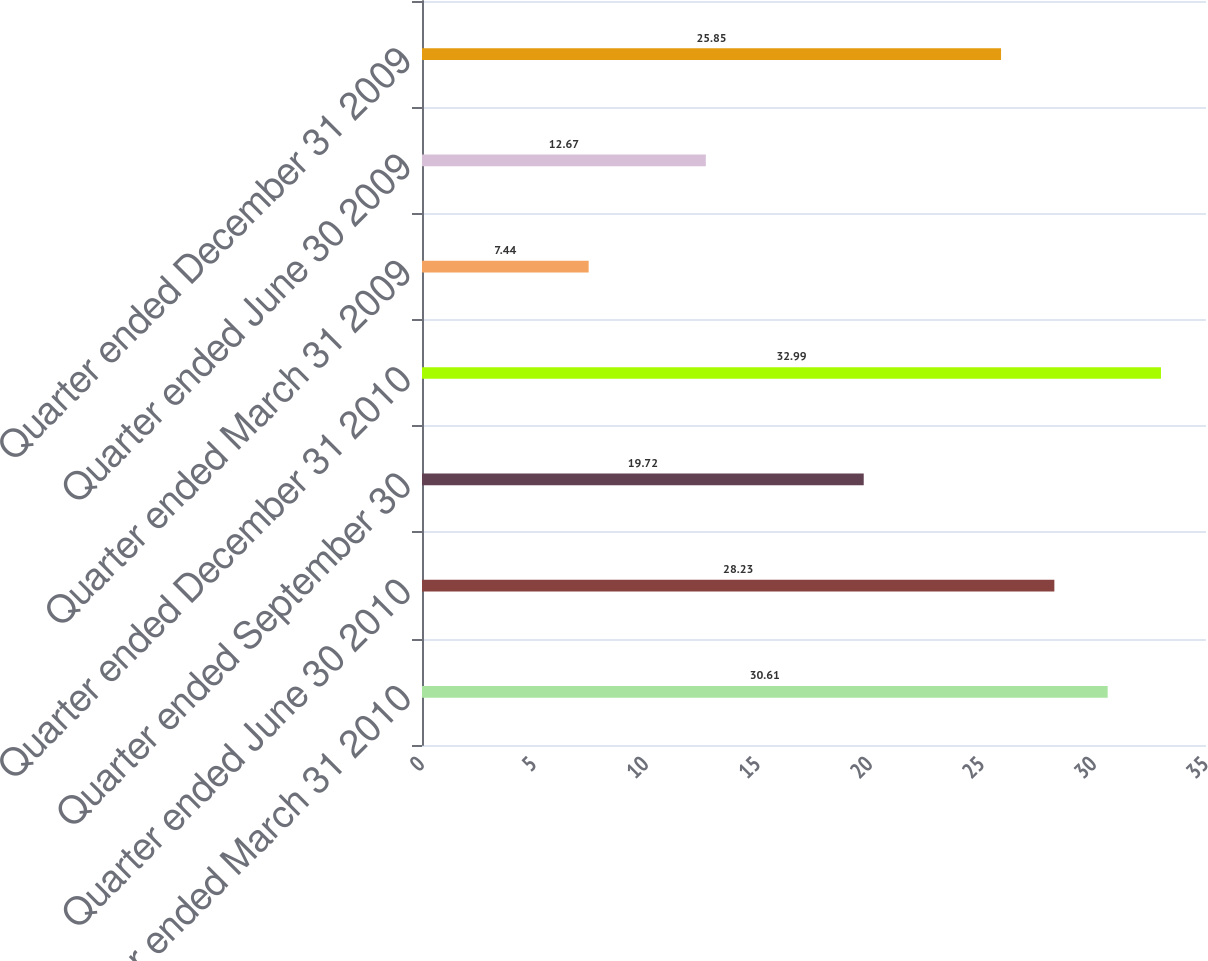Convert chart to OTSL. <chart><loc_0><loc_0><loc_500><loc_500><bar_chart><fcel>Quarter ended March 31 2010<fcel>Quarter ended June 30 2010<fcel>Quarter ended September 30<fcel>Quarter ended December 31 2010<fcel>Quarter ended March 31 2009<fcel>Quarter ended June 30 2009<fcel>Quarter ended December 31 2009<nl><fcel>30.61<fcel>28.23<fcel>19.72<fcel>32.99<fcel>7.44<fcel>12.67<fcel>25.85<nl></chart> 